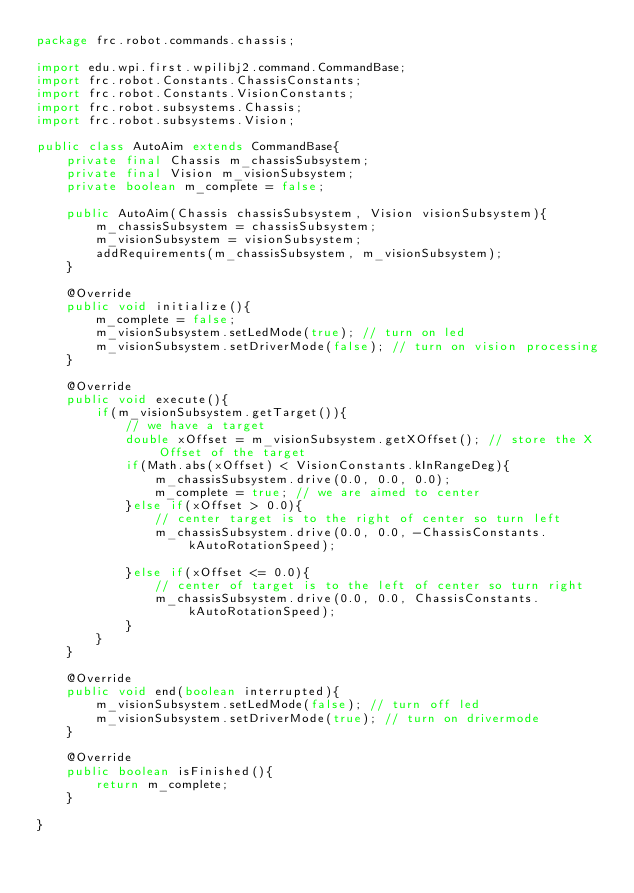<code> <loc_0><loc_0><loc_500><loc_500><_Java_>package frc.robot.commands.chassis;

import edu.wpi.first.wpilibj2.command.CommandBase;
import frc.robot.Constants.ChassisConstants;
import frc.robot.Constants.VisionConstants;
import frc.robot.subsystems.Chassis;
import frc.robot.subsystems.Vision;

public class AutoAim extends CommandBase{
    private final Chassis m_chassisSubsystem;
    private final Vision m_visionSubsystem;
    private boolean m_complete = false;

    public AutoAim(Chassis chassisSubsystem, Vision visionSubsystem){
        m_chassisSubsystem = chassisSubsystem;
        m_visionSubsystem = visionSubsystem;
        addRequirements(m_chassisSubsystem, m_visionSubsystem);
    }
    
    @Override
    public void initialize(){
        m_complete = false;
        m_visionSubsystem.setLedMode(true); // turn on led
        m_visionSubsystem.setDriverMode(false); // turn on vision processing
    }

    @Override
    public void execute(){
        if(m_visionSubsystem.getTarget()){
            // we have a target
            double xOffset = m_visionSubsystem.getXOffset(); // store the X Offset of the target
            if(Math.abs(xOffset) < VisionConstants.kInRangeDeg){
                m_chassisSubsystem.drive(0.0, 0.0, 0.0);
                m_complete = true; // we are aimed to center
            }else if(xOffset > 0.0){
                // center target is to the right of center so turn left
                m_chassisSubsystem.drive(0.0, 0.0, -ChassisConstants.kAutoRotationSpeed);

            }else if(xOffset <= 0.0){
                // center of target is to the left of center so turn right
                m_chassisSubsystem.drive(0.0, 0.0, ChassisConstants.kAutoRotationSpeed);
            }
        }
    }

    @Override
    public void end(boolean interrupted){
        m_visionSubsystem.setLedMode(false); // turn off led
        m_visionSubsystem.setDriverMode(true); // turn on drivermode
    }

    @Override
    public boolean isFinished(){
        return m_complete;
    }

}
</code> 